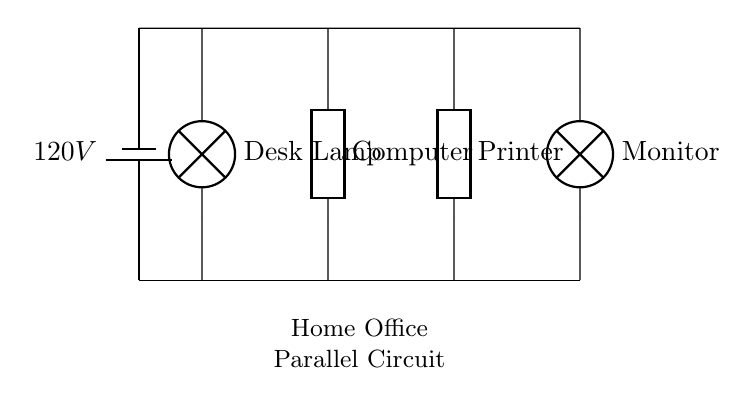What is the voltage of this circuit? The voltage is 120V, as indicated by the battery in the circuit diagram. This value represents the potential difference supplied to the entire circuit.
Answer: 120V What components are connected in this parallel circuit? The components are a desk lamp, a computer, a printer, and a monitor. Each of these devices is connected in parallel to the power source, meaning they share the same voltage but operate independently.
Answer: Desk Lamp, Computer, Printer, Monitor How many power outlets does this circuit support? The circuit diagram supports four outlets, corresponding to the connections for the desk lamp, computer, printer, and monitor. Each component represents an outlet where devices can be plugged in.
Answer: Four Is there a specific component that requires the most power? The computer typically requires the most power compared to the other components, which usually consume less power like lamps or monitors. In a home office setup, computers tend to have higher power requirements for processing.
Answer: Computer How does the current behave in this parallel circuit? In a parallel circuit, the current splits among the branches. Each device or component gets the same voltage but draws its own current based on its resistance. Thus, the total current is the sum of the currents through each component.
Answer: Splits among branches What happens if one device fails in this parallel circuit? If one device fails or is disconnected, the other devices will continue to function normally. This is one of the advantages of parallel circuits, as the failure of one path does not affect the overall operation of the others.
Answer: Others continue to function 